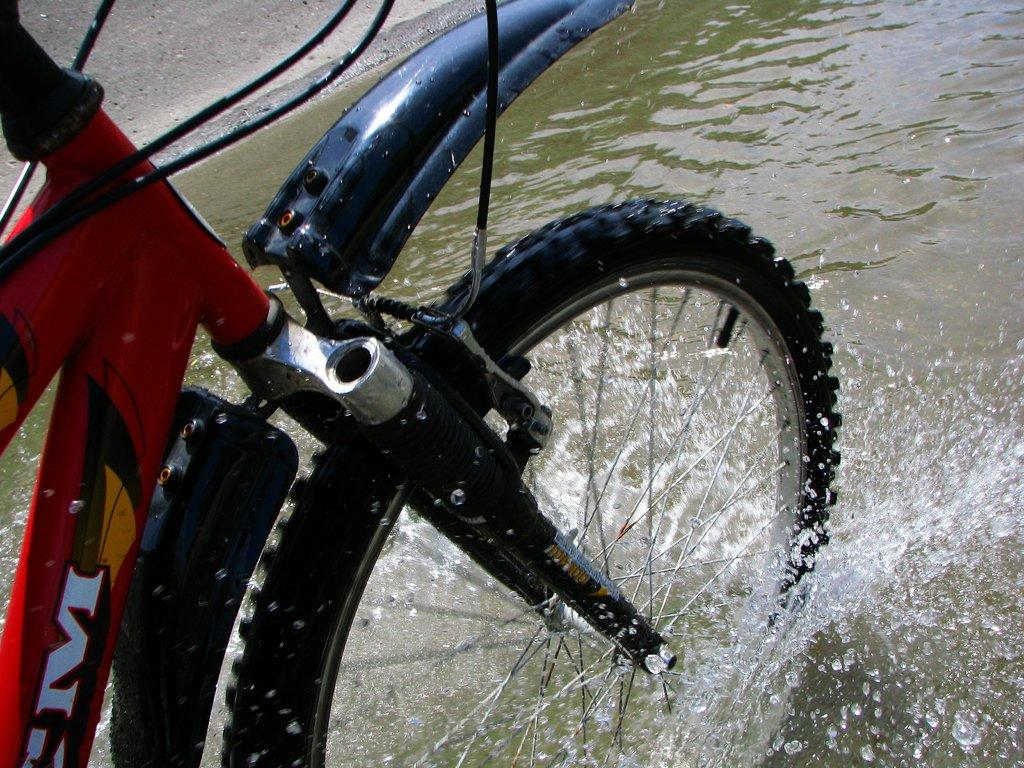What object is partially submerged in water in the image? There is a tire of a bicycle in the image, and it is in water. Can you describe the setting of the image? The tire is in water, which suggests that the image might be taken near a body of water or in a wet environment. What type of prose can be seen in the image? There is no prose present in the image; it features a tire of a bicycle in water. How many waves can be seen in the image? There are no waves visible in the image, as it only shows a tire of a bicycle in water. 